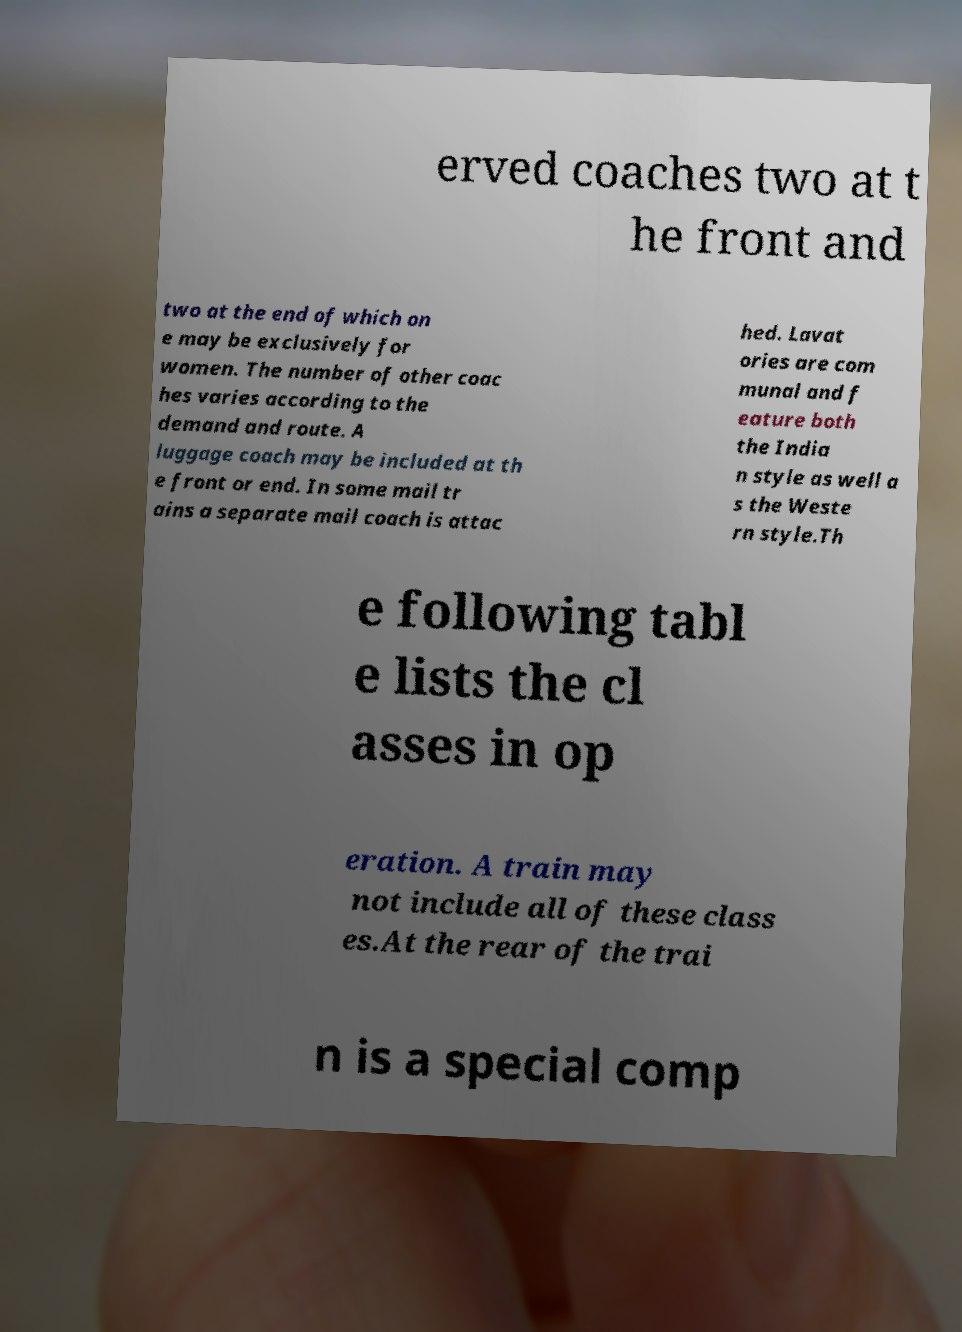Can you accurately transcribe the text from the provided image for me? erved coaches two at t he front and two at the end of which on e may be exclusively for women. The number of other coac hes varies according to the demand and route. A luggage coach may be included at th e front or end. In some mail tr ains a separate mail coach is attac hed. Lavat ories are com munal and f eature both the India n style as well a s the Weste rn style.Th e following tabl e lists the cl asses in op eration. A train may not include all of these class es.At the rear of the trai n is a special comp 